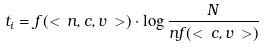<formula> <loc_0><loc_0><loc_500><loc_500>t _ { i } = f ( < \, n , c , v \, > ) \cdot \log \frac { N } { n f ( < \, c , v \, > ) }</formula> 